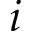<formula> <loc_0><loc_0><loc_500><loc_500>i</formula> 